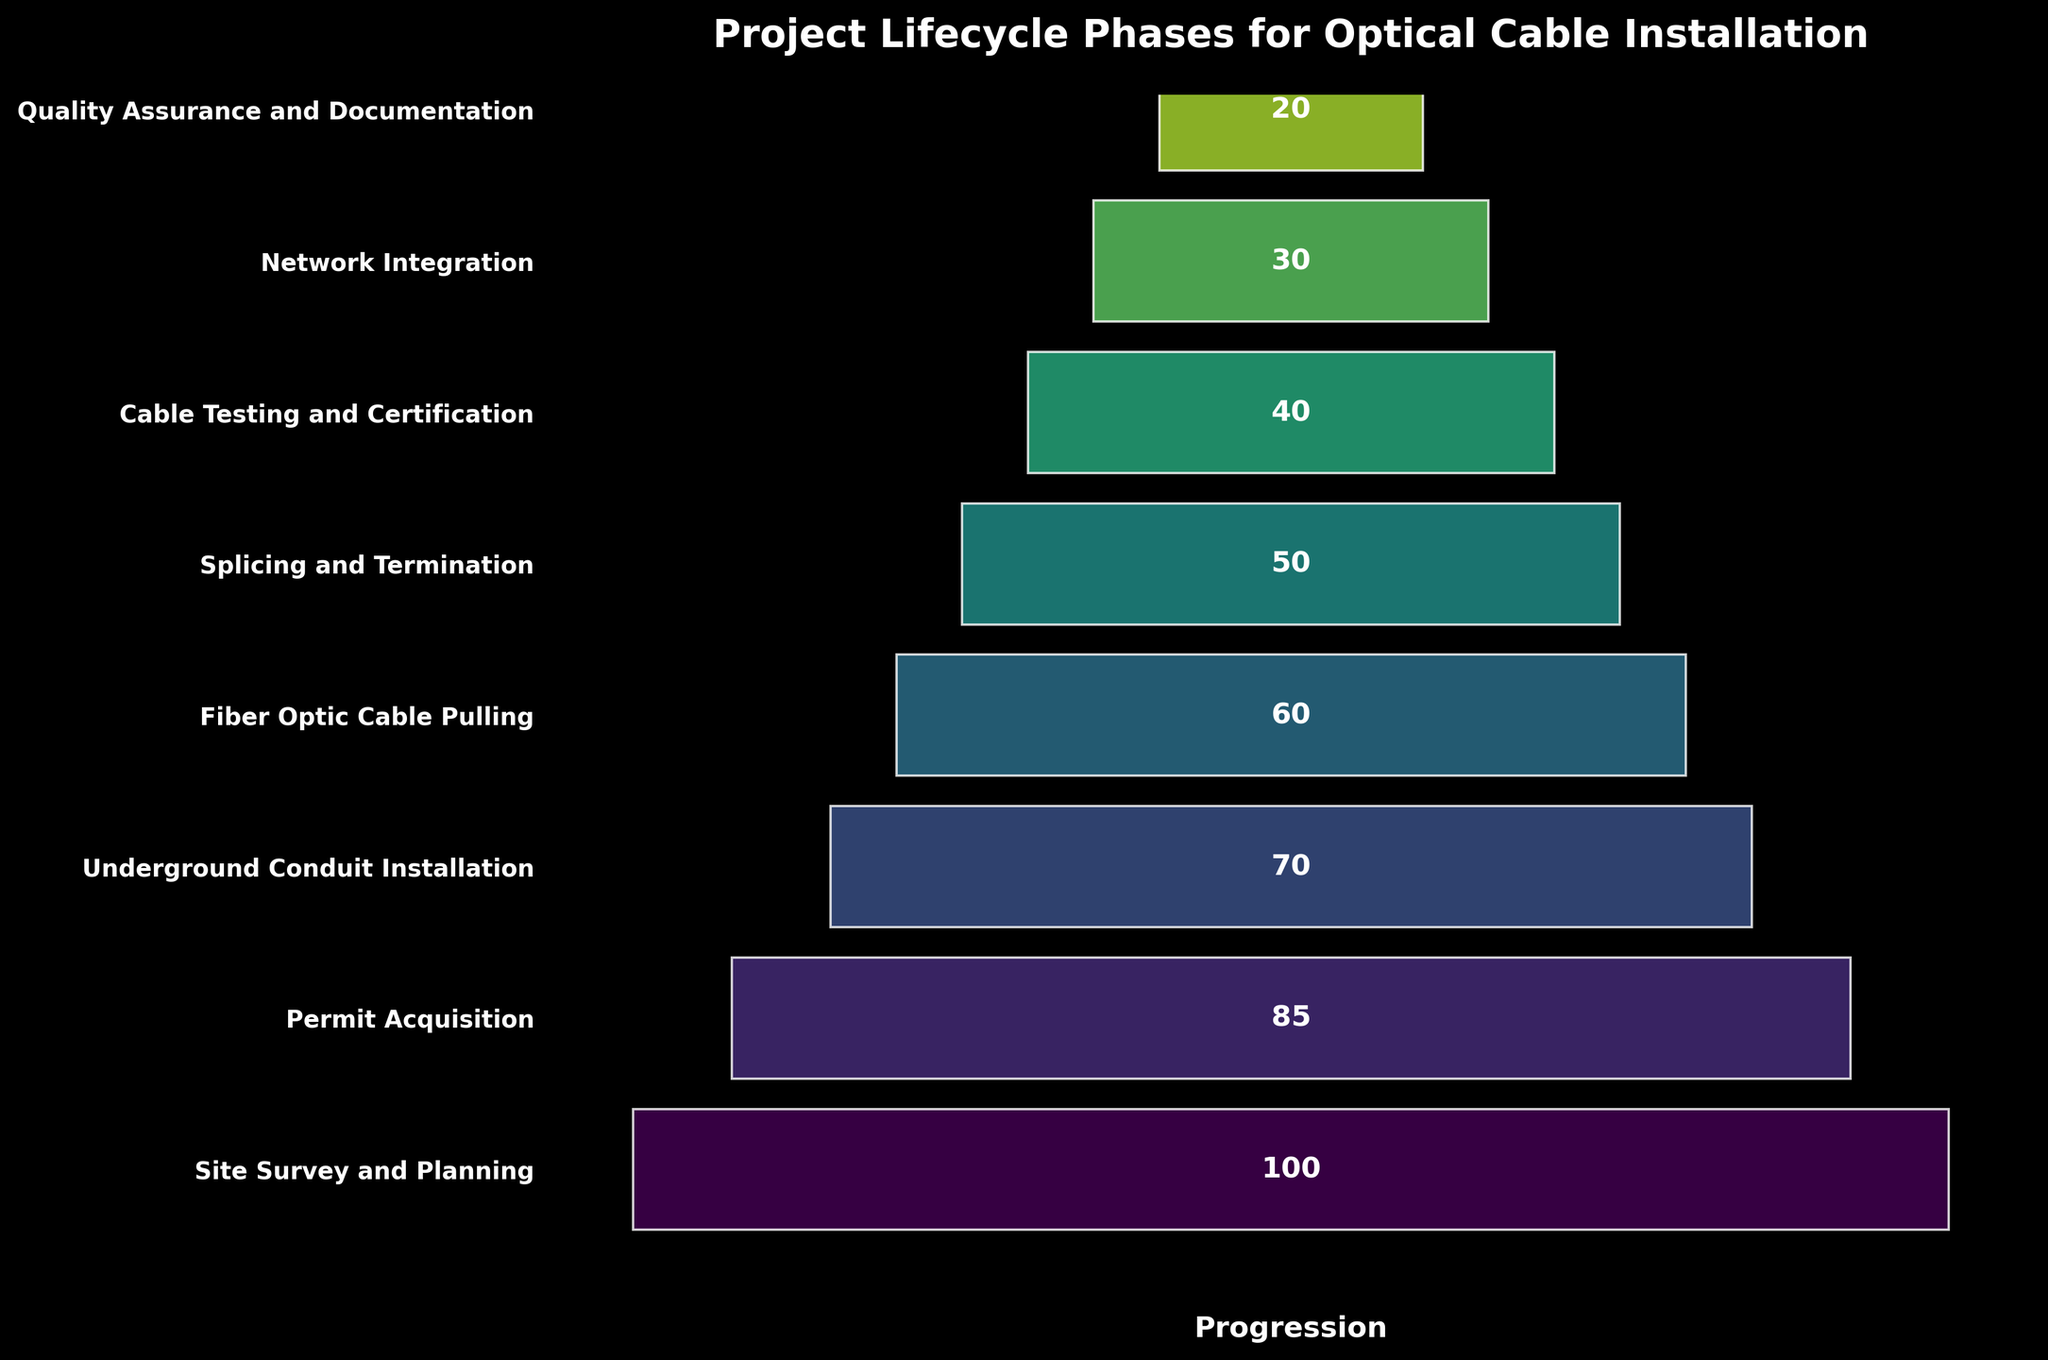What is the title of the figure? The title of the figure is often placed at the top, providing an overview of what the figure represents. In this case, the title would be prominently displayed at the top center of the figure.
Answer: Project Lifecycle Phases for Optical Cable Installation Which phase has the highest value? The highest value indicates the initial phase of the funnel, which is generally at the top of the chart. The value is visually larger compared to others.
Answer: Site Survey and Planning What's the sum of values in the phases from "Fiber Optic Cable Pulling" to "Quality Assurance and Documentation"? Sum the values corresponding to each phase mentioned: (60 + 50 + 40 + 30 + 20).
Answer: 200 Which phase experienced the greatest drop in value compared to its preceding phase? Compare the values of each subsequent phase to find the largest decrease. For example, check the difference between "Permit Acquisition" and "Underground Conduit Installation", as well as other pairs. The largest decrease is what we are looking for.
Answer: Underground Conduit Installation How many phases have a value less than 50? Count the number of phases that, according to their values, are less than 50. This includes the phases "Cable Testing and Certification", "Network Integration", and "Quality Assurance and Documentation".
Answer: 3 What is the average value of all phases combined? Add all the values and then divide by the number of phases (100 + 85 + 70 + 60 + 50 + 40 + 30 + 20) / 8.
Answer: 56.875 Which two consecutive phases have the smallest difference in their values? Subtract each phase value from the next and find the smallest difference. The smallest difference is between "Fiber Optic Cable Pulling" and "Splicing and Termination" (60-50), which is 10.
Answer: Fiber Optic Cable Pulling and Splicing and Termination What percentage of the total value is contributed by the "Network Integration" phase? Calculate the contribution of the "Network Integration" phase (30) divided by the total sum of all phases, then multiply by 100 to get the percentage. (30 / 455) * 100.
Answer: 6.59% Which phase comes right after "Permit Acquisition"? Identify the phase that directly follows "Permit Acquisition" in the sequence. The next phase listed would be "Underground Conduit Installation".
Answer: Underground Conduit Installation How much greater is the value of "Site Survey and Planning" compared to "Splicing and Termination"? Subtract the value of "Splicing and Termination" (50) from "Site Survey and Planning" (100).
Answer: 50 